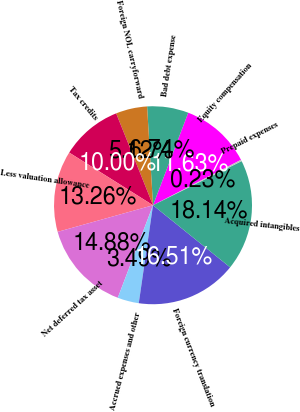Convert chart to OTSL. <chart><loc_0><loc_0><loc_500><loc_500><pie_chart><fcel>Equity compensation<fcel>Bad debt expense<fcel>Foreign NOL carryforward<fcel>Tax credits<fcel>Less valuation allowance<fcel>Net deferred tax asset<fcel>Accrued expenses and other<fcel>Foreign currency translation<fcel>Acquired intangibles<fcel>Prepaid expenses<nl><fcel>11.63%<fcel>6.74%<fcel>5.12%<fcel>10.0%<fcel>13.26%<fcel>14.88%<fcel>3.49%<fcel>16.51%<fcel>18.14%<fcel>0.23%<nl></chart> 